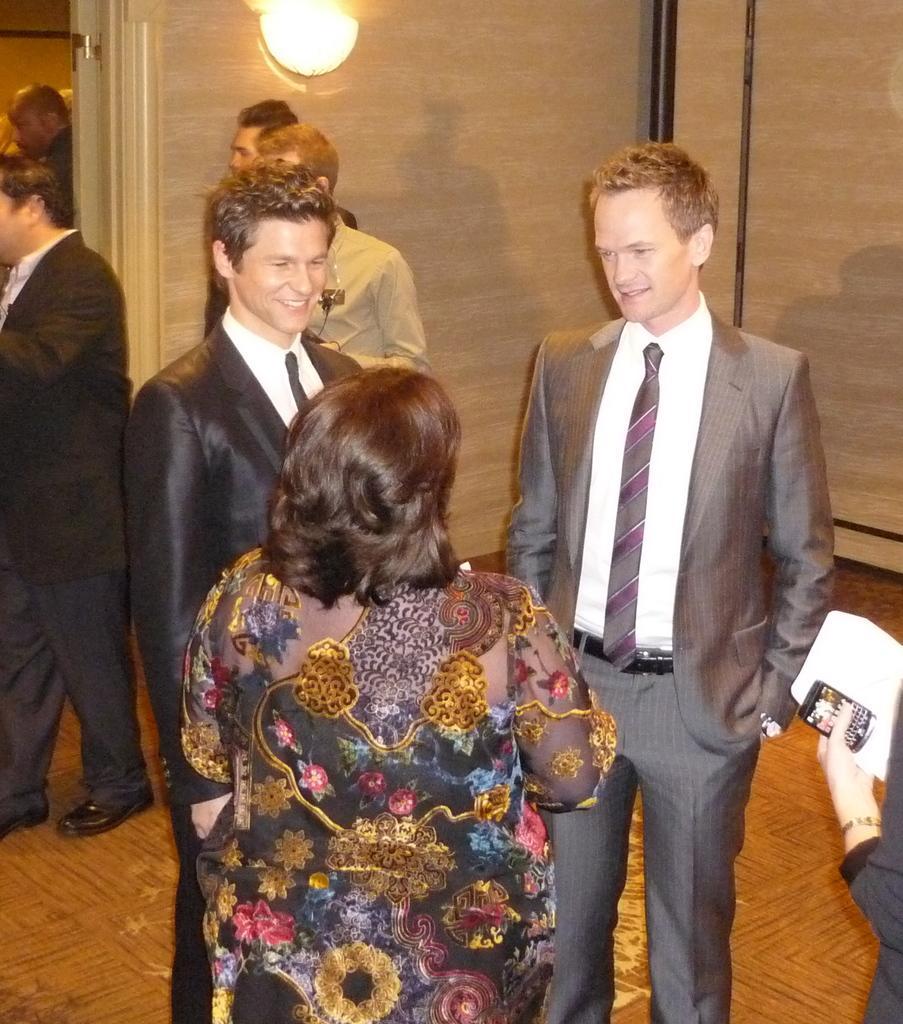Describe this image in one or two sentences. There are few people standing. This looks like a lamp, which is attached to a wall. On the right side of the image, I can see a person's hand holding a mobile phone and a paper. At the bottom of the image, I can see a floor. 